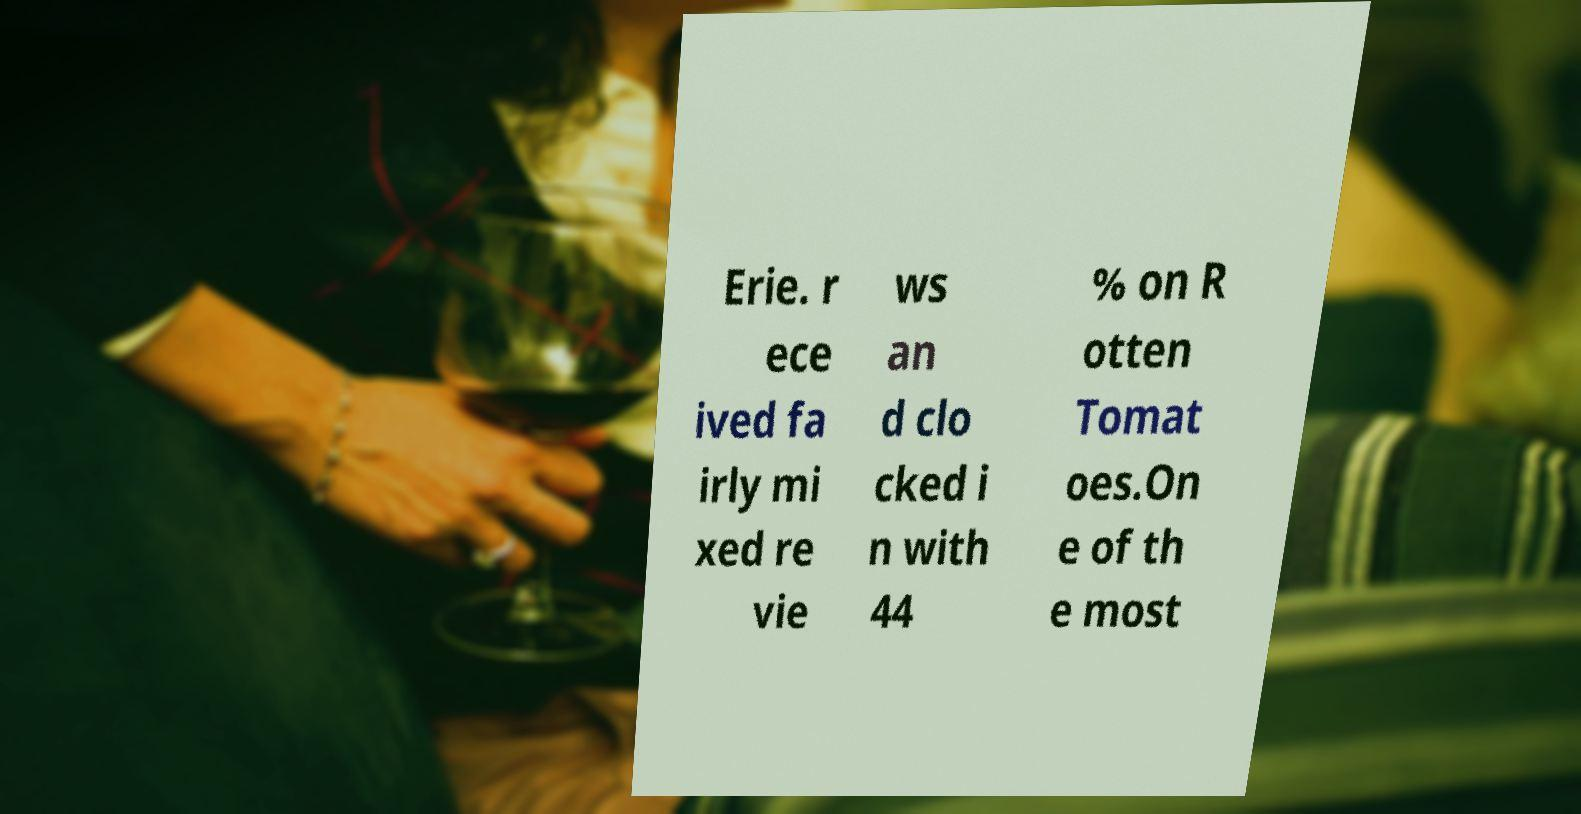There's text embedded in this image that I need extracted. Can you transcribe it verbatim? Erie. r ece ived fa irly mi xed re vie ws an d clo cked i n with 44 % on R otten Tomat oes.On e of th e most 